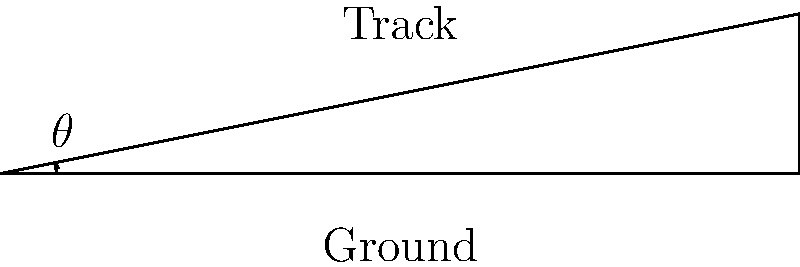As a locomotive climbs a graded section of track, you need to estimate the angle of inclination. Given that the track rises 2 feet over a horizontal distance of 10 feet, what is the approximate angle of inclination in degrees? To find the angle of inclination, we can use basic trigonometry:

1. We have a right triangle where:
   - The adjacent side (horizontal distance) is 10 feet
   - The opposite side (vertical rise) is 2 feet

2. We can use the tangent function to find the angle:

   $\tan(\theta) = \frac{\text{opposite}}{\text{adjacent}} = \frac{2}{10} = 0.2$

3. To find the angle, we need to use the inverse tangent (arctan or $\tan^{-1}$):

   $\theta = \tan^{-1}(0.2)$

4. Using a calculator or trigonometric tables:

   $\theta \approx 11.31^\circ$

5. Rounding to the nearest degree:

   $\theta \approx 11^\circ$

This angle represents a grade of about 3.5%, which is considered a moderate grade for most locomotives.
Answer: $11^\circ$ 